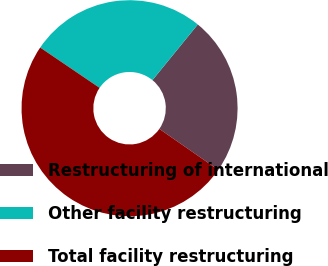Convert chart. <chart><loc_0><loc_0><loc_500><loc_500><pie_chart><fcel>Restructuring of international<fcel>Other facility restructuring<fcel>Total facility restructuring<nl><fcel>23.78%<fcel>26.39%<fcel>49.83%<nl></chart> 